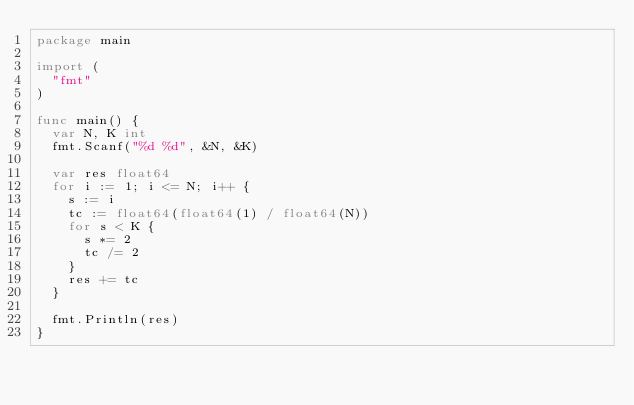<code> <loc_0><loc_0><loc_500><loc_500><_Go_>package main

import (
	"fmt"
)

func main() {
	var N, K int
	fmt.Scanf("%d %d", &N, &K)

	var res float64
	for i := 1; i <= N; i++ {
		s := i
		tc := float64(float64(1) / float64(N))
		for s < K {
			s *= 2
			tc /= 2
		}
		res += tc
	}

	fmt.Println(res)
}
</code> 